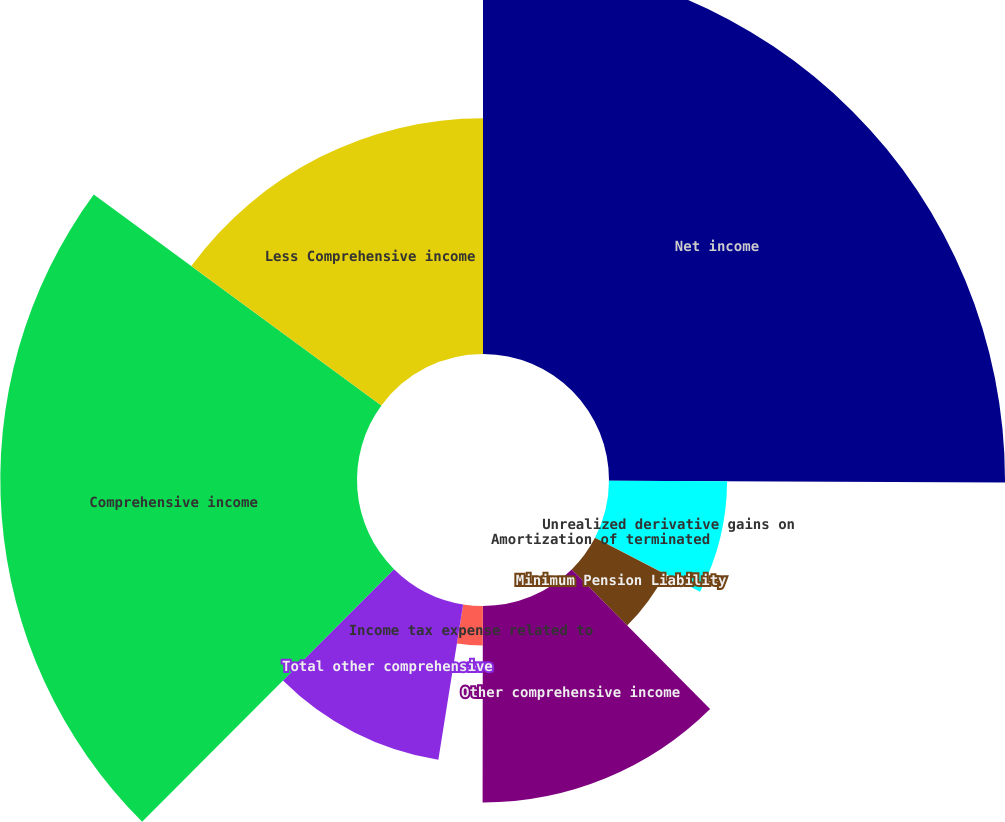<chart> <loc_0><loc_0><loc_500><loc_500><pie_chart><fcel>Net income<fcel>Unrealized derivative gains on<fcel>Amortization of terminated<fcel>Minimum Pension Liability<fcel>Other comprehensive income<fcel>Income tax expense related to<fcel>Total other comprehensive<fcel>Comprehensive income<fcel>Less Comprehensive income<nl><fcel>25.08%<fcel>7.48%<fcel>0.02%<fcel>4.99%<fcel>12.45%<fcel>2.5%<fcel>9.96%<fcel>22.59%<fcel>14.93%<nl></chart> 